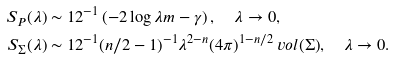<formula> <loc_0><loc_0><loc_500><loc_500>S _ { P } ( \lambda ) & \sim 1 2 ^ { - 1 } \left ( - 2 \log { \lambda m } - \gamma \right ) , \quad \lambda \to 0 , \\ S _ { \Sigma } ( \lambda ) & \sim 1 2 ^ { - 1 } ( n / 2 - 1 ) ^ { - 1 } \lambda ^ { 2 - n } ( 4 \pi ) ^ { 1 - n / 2 } \ v o l { ( \Sigma ) } , \quad \lambda \to 0 .</formula> 